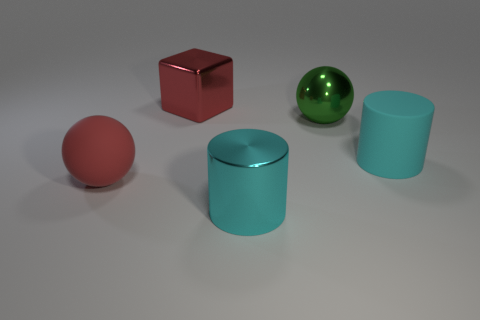How many other big things have the same shape as the green metallic object?
Make the answer very short. 1. The cyan shiny thing is what shape?
Offer a very short reply. Cylinder. Are there the same number of big green objects behind the large green sphere and red objects?
Give a very brief answer. No. Are the cylinder in front of the matte cylinder and the red ball made of the same material?
Give a very brief answer. No. Is the number of things that are in front of the large metallic ball less than the number of big things?
Keep it short and to the point. Yes. How many metal objects are red cubes or green spheres?
Provide a short and direct response. 2. Is the metal block the same color as the matte sphere?
Offer a very short reply. Yes. Is there any other thing of the same color as the matte sphere?
Your answer should be very brief. Yes. There is a big rubber thing left of the red metallic thing; is it the same shape as the large rubber object that is on the right side of the red shiny block?
Provide a succinct answer. No. How many objects are small green metal objects or matte things on the left side of the big green metal sphere?
Make the answer very short. 1. 